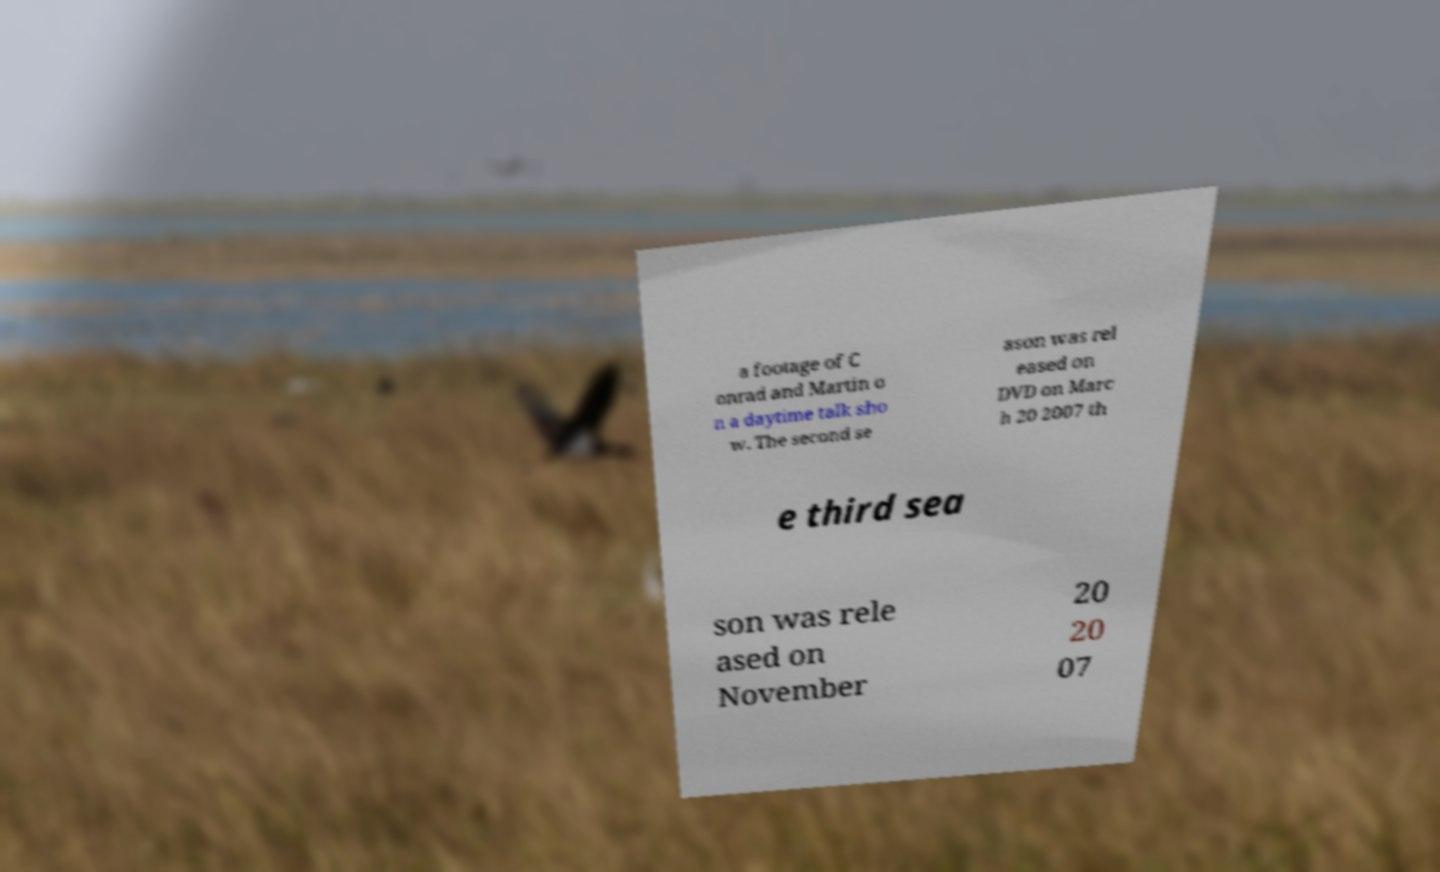Can you read and provide the text displayed in the image?This photo seems to have some interesting text. Can you extract and type it out for me? a footage of C onrad and Martin o n a daytime talk sho w. The second se ason was rel eased on DVD on Marc h 20 2007 th e third sea son was rele ased on November 20 20 07 